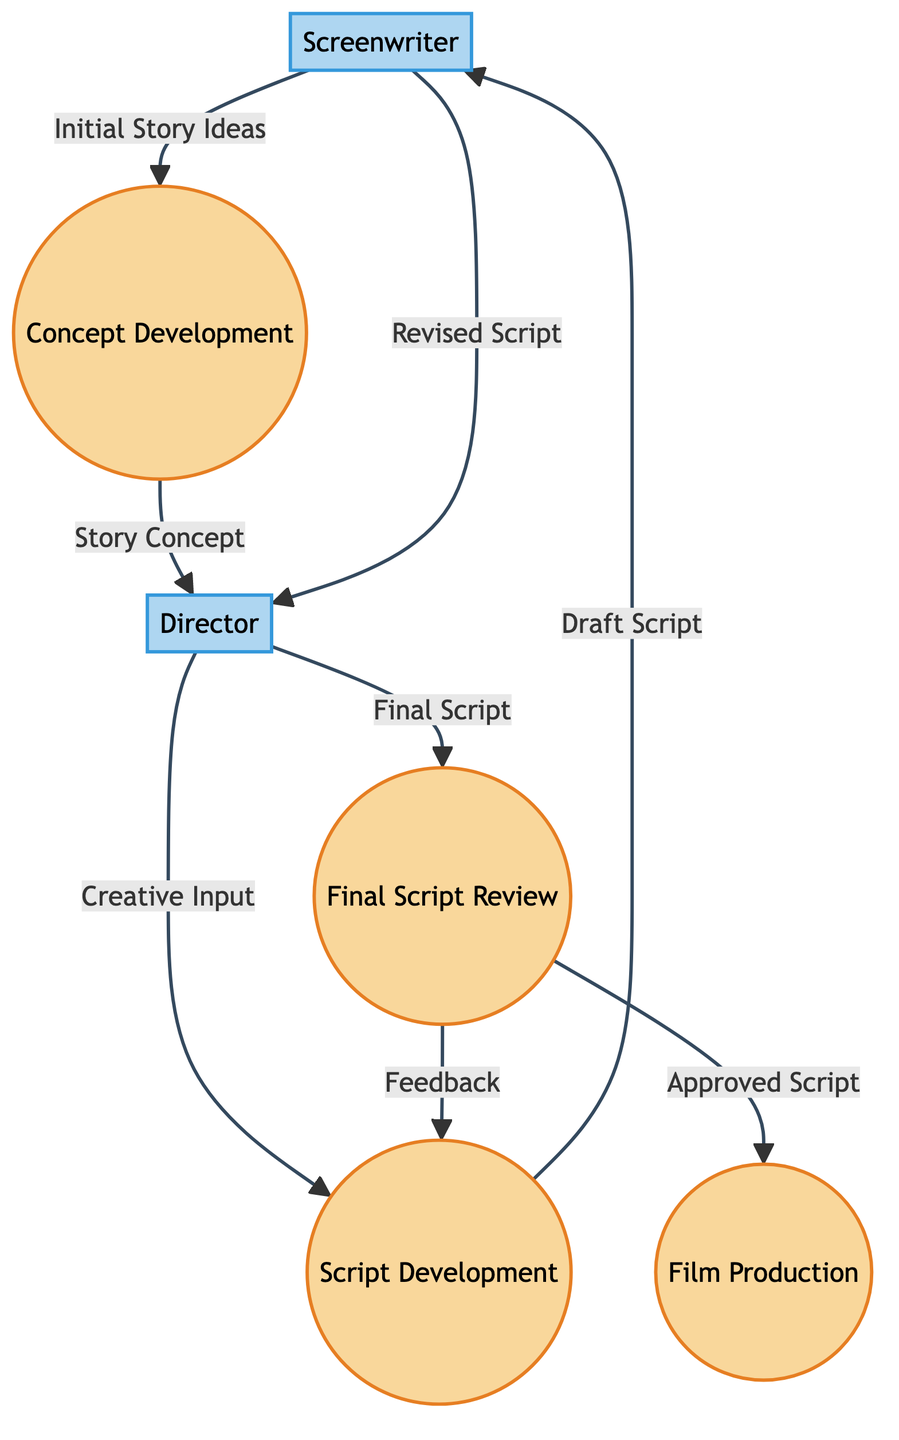What is the first process in the diagram? The first process listed in the diagram is "Concept Development," which is the initial step where the Screenwriter contributes initial story ideas.
Answer: Concept Development How many external entities are present in the diagram? There are two external entities listed: Screenwriter and Director. Therefore, the count is two.
Answer: 2 Which entity receives the "Draft Script"? The "Draft Script" is sent to the Screenwriter from the Script Development process. Thus, the recipient is the Screenwriter.
Answer: Screenwriter What is the label of the flow from the Director to the Script Development? The label of the flow from the Director to the Script Development process is "Creative Input." This flow indicates the Director's contributions to developing the script.
Answer: Creative Input How many processes are involved in the collaboration between screenwriters and directors? The diagram lists four distinct processes: Concept Development, Script Development, Final Script Review, and Film Production. Therefore, the total number of processes is four.
Answer: 4 What does the Final Script Review process output to Film Production? The output from the Final Script Review process to Film Production is labeled "Approved Script," which indicates the final script ready for production.
Answer: Approved Script Which process is related to the feedback loop in the diagram? The feedback loop is facilitated by the "Final Script Review" process, which sends "Feedback" back to the Script Development process, indicating a cyclical review process.
Answer: Final Script Review What is the last step in the diagram that a Director is involved with? The last step involving the Director is the receipt of the "Final Script," which they provide before the Final Script Review occurs.
Answer: Final Script What flow starts with initial ideas from the Screenwriter? The flow that starts with initial ideas from the Screenwriter is labeled "Initial Story Ideas," leading to the Concept Development process.
Answer: Initial Story Ideas 